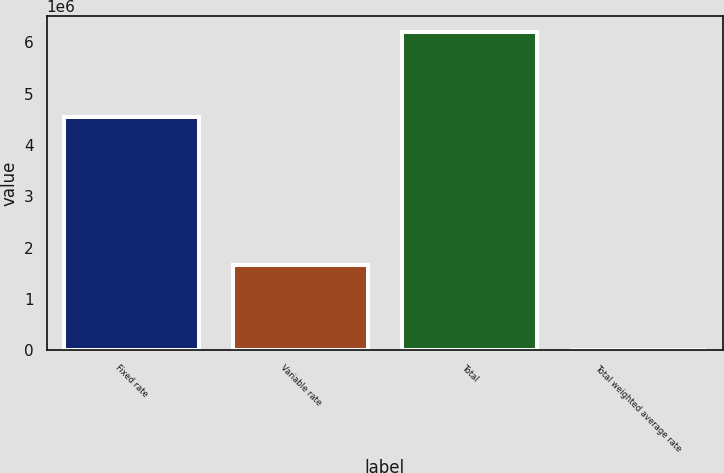<chart> <loc_0><loc_0><loc_500><loc_500><bar_chart><fcel>Fixed rate<fcel>Variable rate<fcel>Total<fcel>Total weighted average rate<nl><fcel>4.54124e+06<fcel>1.66903e+06<fcel>6.21027e+06<fcel>5.97<nl></chart> 